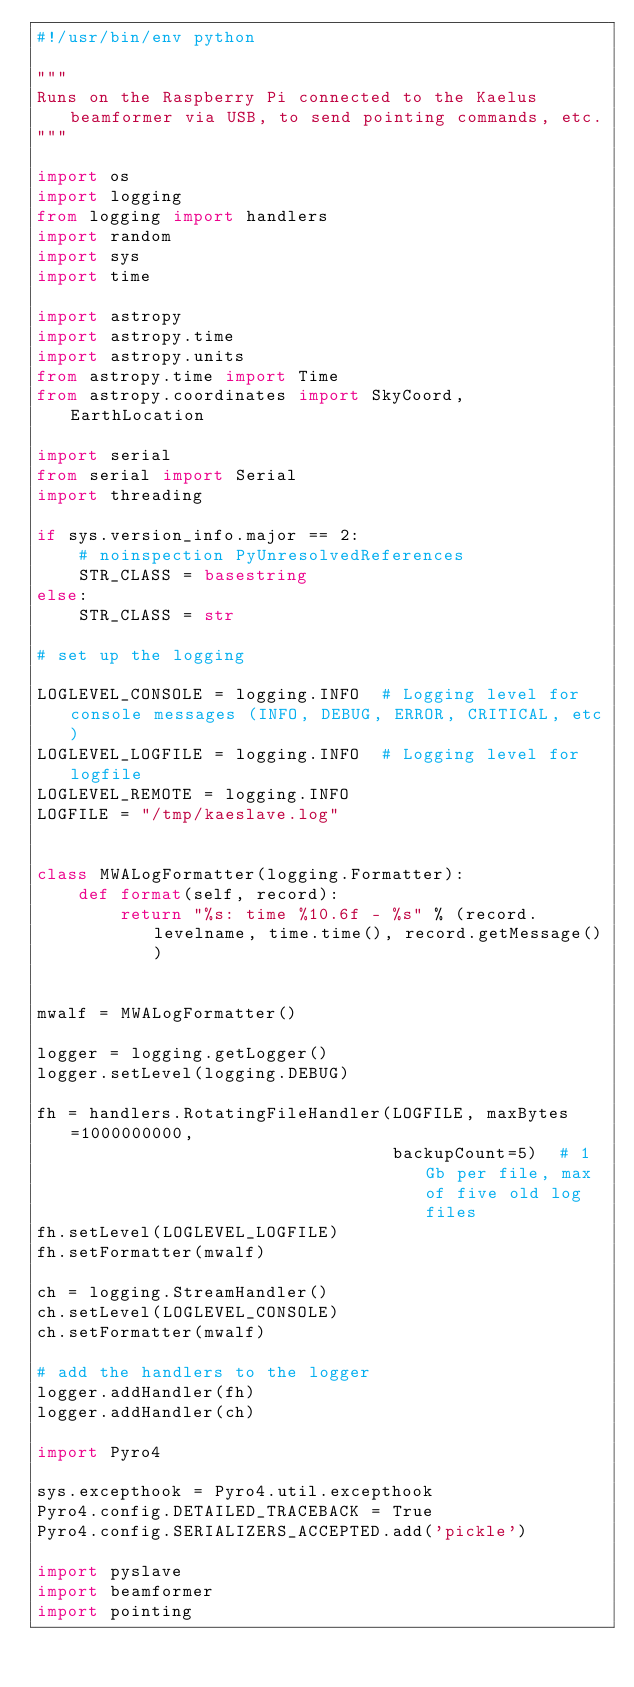<code> <loc_0><loc_0><loc_500><loc_500><_Python_>#!/usr/bin/env python

"""
Runs on the Raspberry Pi connected to the Kaelus beamformer via USB, to send pointing commands, etc.
"""

import os
import logging
from logging import handlers
import random
import sys
import time

import astropy
import astropy.time
import astropy.units
from astropy.time import Time
from astropy.coordinates import SkyCoord, EarthLocation

import serial
from serial import Serial
import threading

if sys.version_info.major == 2:
    # noinspection PyUnresolvedReferences
    STR_CLASS = basestring
else:
    STR_CLASS = str

# set up the logging

LOGLEVEL_CONSOLE = logging.INFO  # Logging level for console messages (INFO, DEBUG, ERROR, CRITICAL, etc)
LOGLEVEL_LOGFILE = logging.INFO  # Logging level for logfile
LOGLEVEL_REMOTE = logging.INFO
LOGFILE = "/tmp/kaeslave.log"


class MWALogFormatter(logging.Formatter):
    def format(self, record):
        return "%s: time %10.6f - %s" % (record.levelname, time.time(), record.getMessage())


mwalf = MWALogFormatter()

logger = logging.getLogger()
logger.setLevel(logging.DEBUG)

fh = handlers.RotatingFileHandler(LOGFILE, maxBytes=1000000000,
                                  backupCount=5)  # 1 Gb per file, max of five old log files
fh.setLevel(LOGLEVEL_LOGFILE)
fh.setFormatter(mwalf)

ch = logging.StreamHandler()
ch.setLevel(LOGLEVEL_CONSOLE)
ch.setFormatter(mwalf)

# add the handlers to the logger
logger.addHandler(fh)
logger.addHandler(ch)

import Pyro4

sys.excepthook = Pyro4.util.excepthook
Pyro4.config.DETAILED_TRACEBACK = True
Pyro4.config.SERIALIZERS_ACCEPTED.add('pickle')

import pyslave
import beamformer
import pointing
</code> 